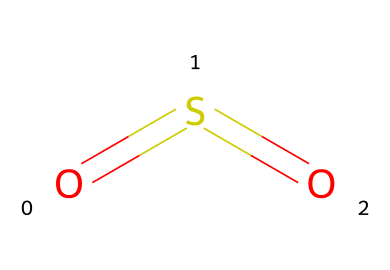What is the total number of atoms in sulfur dioxide? The chemical structure consists of one sulfur atom and two oxygen atoms. Therefore, we add these together: 1 (sulfur) + 2 (oxygen) = 3 total atoms.
Answer: 3 How many double bonds are present in the structure of this chemical? In the given SMILES representation, each "=" symbol represents a double bond. There are two "=" symbols, indicating there are two double bonds in the structure.
Answer: 2 What elemental composition makes up sulfur dioxide? The structure includes sulfur and oxygen atoms. Specifically, there is one sulfur atom and two oxygen atoms present, which collectively determines the elemental composition of sulfur dioxide (SO2).
Answer: SO2 What is the oxidation state of sulfur in sulfur dioxide? In sulfur dioxide, sulfur typically has an oxidation state of +4. This can be determined by considering the usual oxidation states of oxygen (-2) and balancing them with the total oxidation of the molecule.
Answer: +4 Is sulfur dioxide a molecular or ionic compound? Sulfur dioxide is a molecular compound because it is formed by covalent bonds between nonmetals (sulfur and oxygen) rather than being composed of ions.
Answer: molecular What is the molecular geometry of sulfur dioxide? The molecular geometry of sulfur dioxide can be determined from the arrangement of the three atoms (one sulfur and two oxygen). This arrangement leads to a bent or V-shape due to the repulsion of the lone pairs of electrons on the sulfur.
Answer: bent 